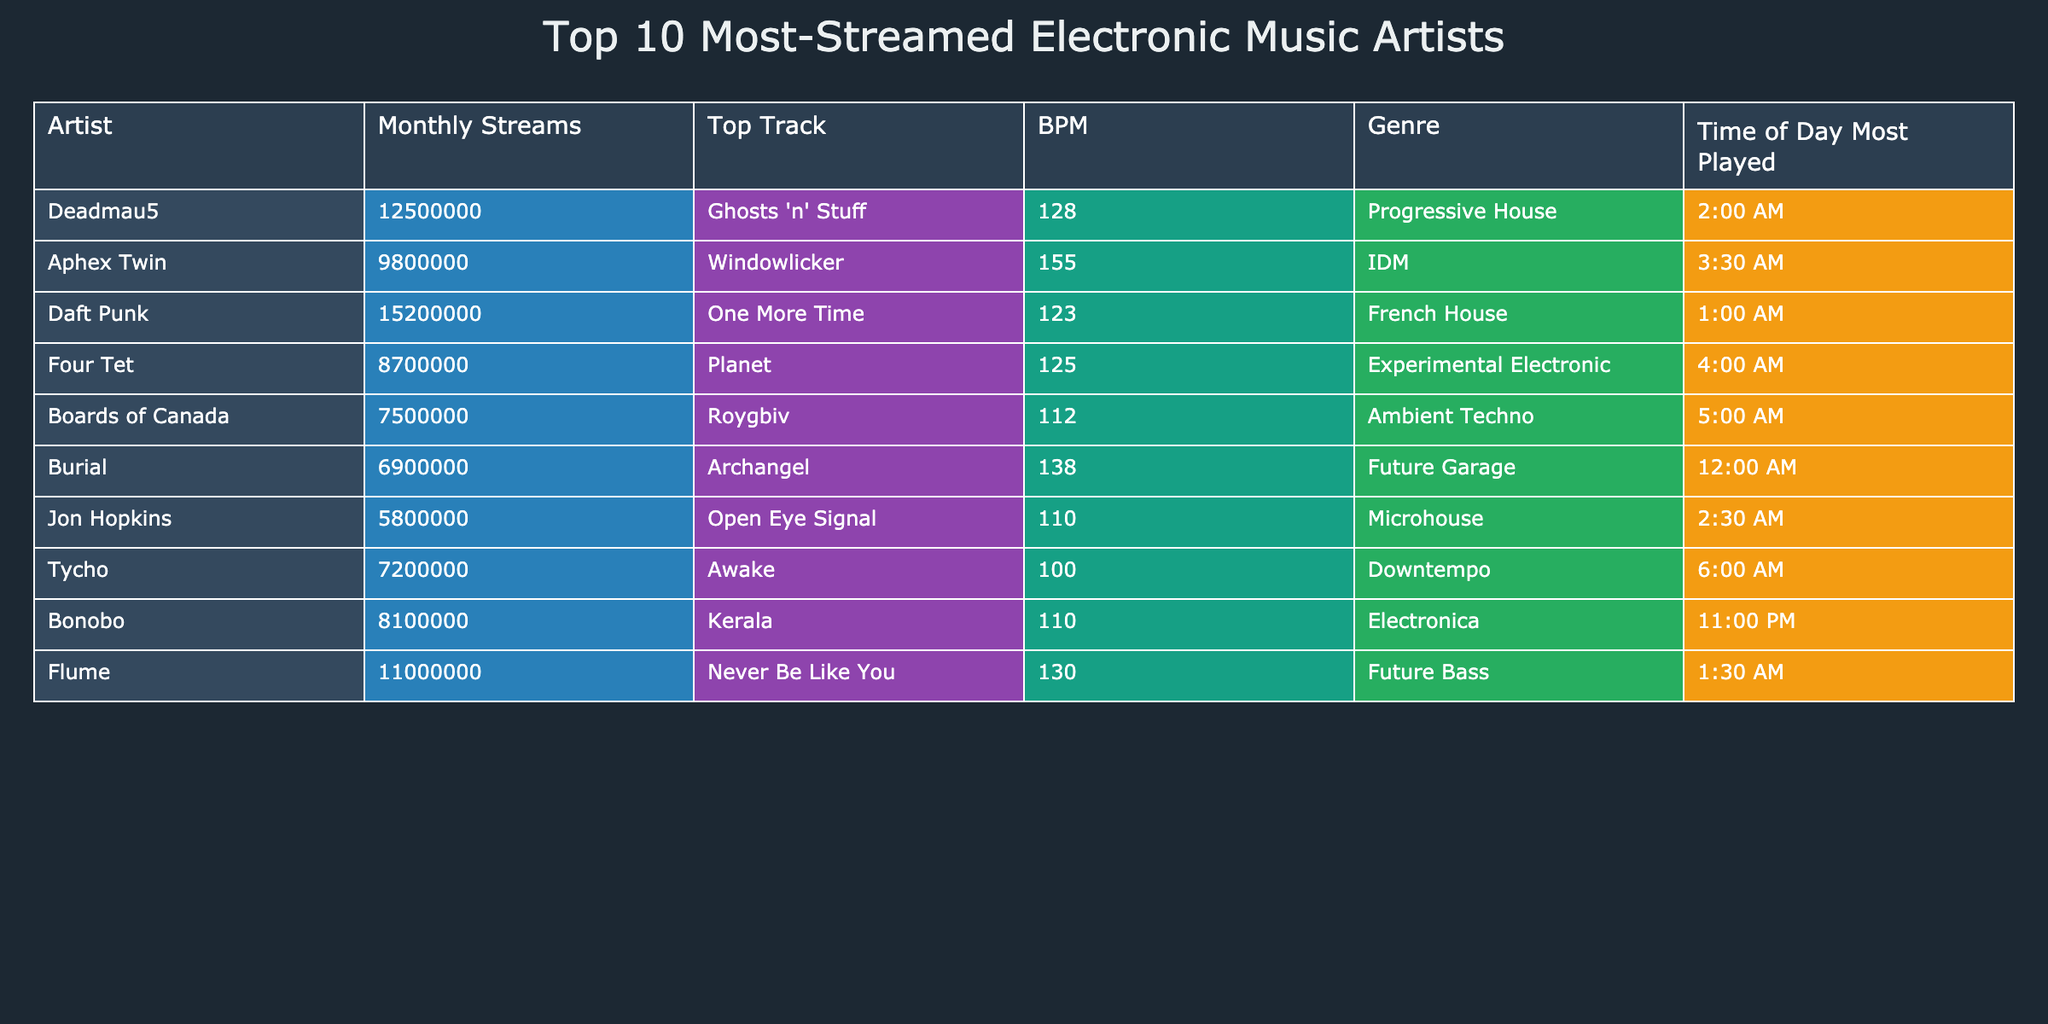What is the top track of Daft Punk? According to the table, Daft Punk's top track listed is "One More Time."
Answer: One More Time Which artist has the highest monthly streams? By checking the "Monthly Streams" column, Daft Punk has the highest number of streams at 15,200,000.
Answer: Daft Punk How many artists have a BPM above 130? The artists with a BPM above 130 are Aphex Twin (155), Burial (138), and Flume (130). Therefore, there are a total of 3 artists with BPM above 130.
Answer: 3 What is the average BPM of the artists listed in the table? The BPM values are 128, 155, 123, 125, 112, 138, 110, 100, 110, and 130. Adding them gives 1,241. Dividing by the total number of artists, 10, the average BPM is 124.1.
Answer: 124.1 Does any artist have the same time of day most played as Flume? Flume is most played at 1:30 AM. Checking the "Time of Day Most Played" column, only Daft Punk (1:00 AM) and Deadmau5 (2:00 AM) are listed; therefore, no artist matches.
Answer: No 